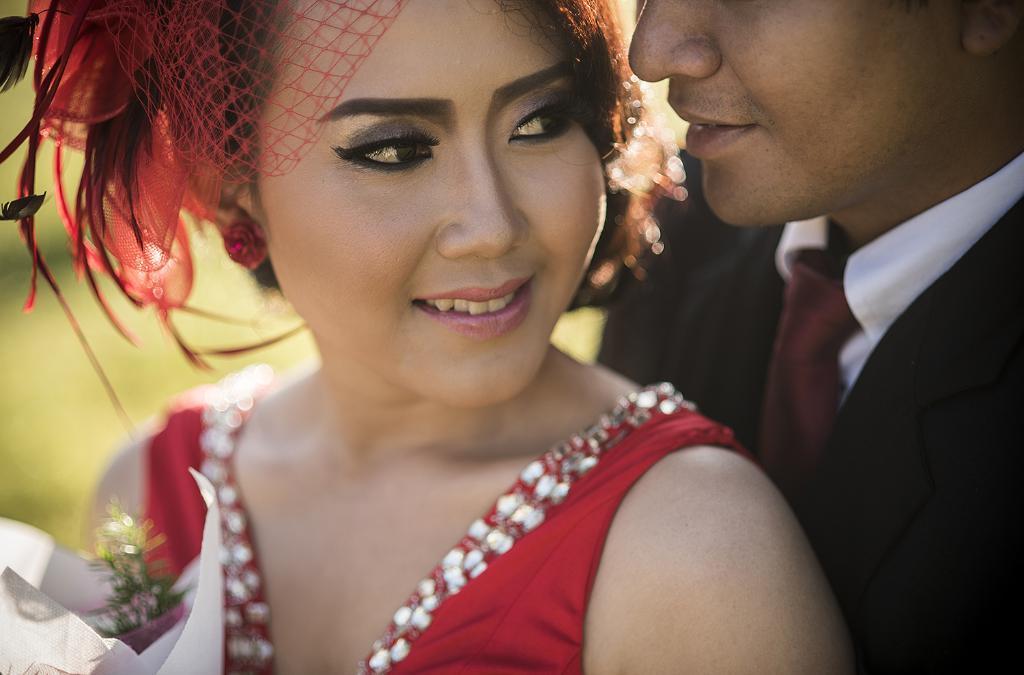Please provide a concise description of this image. In this picture I can see a girl at the center, she is wearing a red color dress. On the right side there is a man, he is wearing a tie, shirt and a coat. 